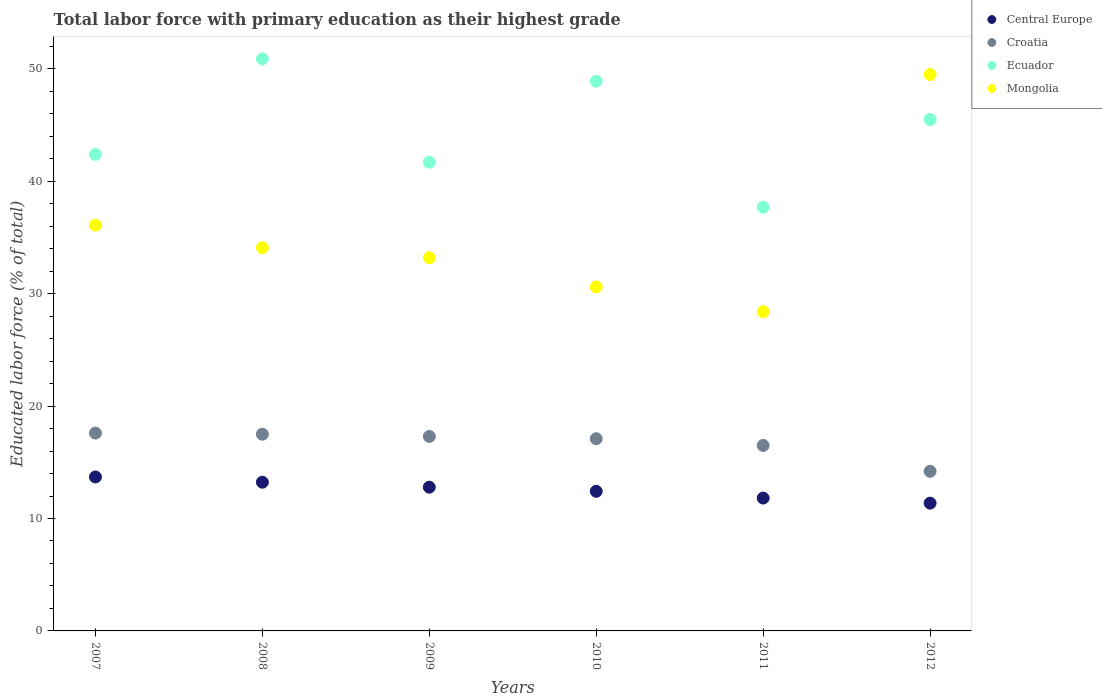What is the percentage of total labor force with primary education in Ecuador in 2009?
Offer a very short reply. 41.7. Across all years, what is the maximum percentage of total labor force with primary education in Ecuador?
Offer a very short reply. 50.9. Across all years, what is the minimum percentage of total labor force with primary education in Central Europe?
Your response must be concise. 11.37. What is the total percentage of total labor force with primary education in Croatia in the graph?
Your response must be concise. 100.2. What is the difference between the percentage of total labor force with primary education in Croatia in 2009 and that in 2010?
Your response must be concise. 0.2. What is the difference between the percentage of total labor force with primary education in Central Europe in 2007 and the percentage of total labor force with primary education in Ecuador in 2010?
Make the answer very short. -35.2. What is the average percentage of total labor force with primary education in Central Europe per year?
Your answer should be very brief. 12.55. In the year 2011, what is the difference between the percentage of total labor force with primary education in Ecuador and percentage of total labor force with primary education in Croatia?
Provide a succinct answer. 21.2. What is the ratio of the percentage of total labor force with primary education in Croatia in 2009 to that in 2010?
Ensure brevity in your answer.  1.01. What is the difference between the highest and the second highest percentage of total labor force with primary education in Mongolia?
Your answer should be very brief. 13.4. What is the difference between the highest and the lowest percentage of total labor force with primary education in Croatia?
Make the answer very short. 3.4. Is it the case that in every year, the sum of the percentage of total labor force with primary education in Ecuador and percentage of total labor force with primary education in Central Europe  is greater than the sum of percentage of total labor force with primary education in Croatia and percentage of total labor force with primary education in Mongolia?
Your answer should be compact. Yes. Does the percentage of total labor force with primary education in Mongolia monotonically increase over the years?
Your answer should be compact. No. How many dotlines are there?
Make the answer very short. 4. What is the difference between two consecutive major ticks on the Y-axis?
Offer a terse response. 10. Does the graph contain grids?
Keep it short and to the point. No. What is the title of the graph?
Your response must be concise. Total labor force with primary education as their highest grade. Does "Slovenia" appear as one of the legend labels in the graph?
Your response must be concise. No. What is the label or title of the Y-axis?
Make the answer very short. Educated labor force (% of total). What is the Educated labor force (% of total) in Central Europe in 2007?
Offer a terse response. 13.7. What is the Educated labor force (% of total) of Croatia in 2007?
Provide a succinct answer. 17.6. What is the Educated labor force (% of total) in Ecuador in 2007?
Your answer should be very brief. 42.4. What is the Educated labor force (% of total) of Mongolia in 2007?
Make the answer very short. 36.1. What is the Educated labor force (% of total) of Central Europe in 2008?
Provide a succinct answer. 13.23. What is the Educated labor force (% of total) of Ecuador in 2008?
Offer a very short reply. 50.9. What is the Educated labor force (% of total) in Mongolia in 2008?
Your answer should be very brief. 34.1. What is the Educated labor force (% of total) of Central Europe in 2009?
Provide a succinct answer. 12.79. What is the Educated labor force (% of total) in Croatia in 2009?
Your answer should be very brief. 17.3. What is the Educated labor force (% of total) in Ecuador in 2009?
Your response must be concise. 41.7. What is the Educated labor force (% of total) in Mongolia in 2009?
Offer a terse response. 33.2. What is the Educated labor force (% of total) of Central Europe in 2010?
Ensure brevity in your answer.  12.42. What is the Educated labor force (% of total) of Croatia in 2010?
Your answer should be very brief. 17.1. What is the Educated labor force (% of total) in Ecuador in 2010?
Provide a short and direct response. 48.9. What is the Educated labor force (% of total) of Mongolia in 2010?
Make the answer very short. 30.6. What is the Educated labor force (% of total) of Central Europe in 2011?
Your answer should be very brief. 11.82. What is the Educated labor force (% of total) of Ecuador in 2011?
Offer a terse response. 37.7. What is the Educated labor force (% of total) in Mongolia in 2011?
Your answer should be compact. 28.4. What is the Educated labor force (% of total) of Central Europe in 2012?
Provide a succinct answer. 11.37. What is the Educated labor force (% of total) in Croatia in 2012?
Make the answer very short. 14.2. What is the Educated labor force (% of total) in Ecuador in 2012?
Provide a succinct answer. 45.5. What is the Educated labor force (% of total) in Mongolia in 2012?
Give a very brief answer. 49.5. Across all years, what is the maximum Educated labor force (% of total) in Central Europe?
Your answer should be compact. 13.7. Across all years, what is the maximum Educated labor force (% of total) of Croatia?
Provide a short and direct response. 17.6. Across all years, what is the maximum Educated labor force (% of total) in Ecuador?
Provide a succinct answer. 50.9. Across all years, what is the maximum Educated labor force (% of total) of Mongolia?
Keep it short and to the point. 49.5. Across all years, what is the minimum Educated labor force (% of total) of Central Europe?
Ensure brevity in your answer.  11.37. Across all years, what is the minimum Educated labor force (% of total) in Croatia?
Offer a terse response. 14.2. Across all years, what is the minimum Educated labor force (% of total) in Ecuador?
Give a very brief answer. 37.7. Across all years, what is the minimum Educated labor force (% of total) in Mongolia?
Ensure brevity in your answer.  28.4. What is the total Educated labor force (% of total) in Central Europe in the graph?
Give a very brief answer. 75.33. What is the total Educated labor force (% of total) of Croatia in the graph?
Your answer should be very brief. 100.2. What is the total Educated labor force (% of total) in Ecuador in the graph?
Give a very brief answer. 267.1. What is the total Educated labor force (% of total) in Mongolia in the graph?
Keep it short and to the point. 211.9. What is the difference between the Educated labor force (% of total) of Central Europe in 2007 and that in 2008?
Your answer should be very brief. 0.47. What is the difference between the Educated labor force (% of total) in Croatia in 2007 and that in 2008?
Ensure brevity in your answer.  0.1. What is the difference between the Educated labor force (% of total) of Mongolia in 2007 and that in 2008?
Give a very brief answer. 2. What is the difference between the Educated labor force (% of total) of Central Europe in 2007 and that in 2009?
Offer a terse response. 0.91. What is the difference between the Educated labor force (% of total) of Croatia in 2007 and that in 2009?
Your response must be concise. 0.3. What is the difference between the Educated labor force (% of total) of Ecuador in 2007 and that in 2009?
Your answer should be very brief. 0.7. What is the difference between the Educated labor force (% of total) of Mongolia in 2007 and that in 2009?
Provide a short and direct response. 2.9. What is the difference between the Educated labor force (% of total) of Central Europe in 2007 and that in 2010?
Offer a terse response. 1.27. What is the difference between the Educated labor force (% of total) of Ecuador in 2007 and that in 2010?
Give a very brief answer. -6.5. What is the difference between the Educated labor force (% of total) in Mongolia in 2007 and that in 2010?
Ensure brevity in your answer.  5.5. What is the difference between the Educated labor force (% of total) of Central Europe in 2007 and that in 2011?
Your response must be concise. 1.88. What is the difference between the Educated labor force (% of total) of Central Europe in 2007 and that in 2012?
Make the answer very short. 2.33. What is the difference between the Educated labor force (% of total) of Mongolia in 2007 and that in 2012?
Ensure brevity in your answer.  -13.4. What is the difference between the Educated labor force (% of total) of Central Europe in 2008 and that in 2009?
Your response must be concise. 0.44. What is the difference between the Educated labor force (% of total) in Ecuador in 2008 and that in 2009?
Offer a very short reply. 9.2. What is the difference between the Educated labor force (% of total) in Mongolia in 2008 and that in 2009?
Keep it short and to the point. 0.9. What is the difference between the Educated labor force (% of total) in Central Europe in 2008 and that in 2010?
Ensure brevity in your answer.  0.81. What is the difference between the Educated labor force (% of total) of Mongolia in 2008 and that in 2010?
Provide a short and direct response. 3.5. What is the difference between the Educated labor force (% of total) of Central Europe in 2008 and that in 2011?
Make the answer very short. 1.41. What is the difference between the Educated labor force (% of total) in Croatia in 2008 and that in 2011?
Your answer should be compact. 1. What is the difference between the Educated labor force (% of total) in Central Europe in 2008 and that in 2012?
Make the answer very short. 1.86. What is the difference between the Educated labor force (% of total) of Croatia in 2008 and that in 2012?
Your answer should be very brief. 3.3. What is the difference between the Educated labor force (% of total) of Mongolia in 2008 and that in 2012?
Provide a succinct answer. -15.4. What is the difference between the Educated labor force (% of total) of Central Europe in 2009 and that in 2010?
Keep it short and to the point. 0.37. What is the difference between the Educated labor force (% of total) in Croatia in 2009 and that in 2010?
Your answer should be very brief. 0.2. What is the difference between the Educated labor force (% of total) in Ecuador in 2009 and that in 2010?
Provide a short and direct response. -7.2. What is the difference between the Educated labor force (% of total) in Central Europe in 2009 and that in 2011?
Offer a very short reply. 0.97. What is the difference between the Educated labor force (% of total) in Ecuador in 2009 and that in 2011?
Keep it short and to the point. 4. What is the difference between the Educated labor force (% of total) in Mongolia in 2009 and that in 2011?
Your response must be concise. 4.8. What is the difference between the Educated labor force (% of total) in Central Europe in 2009 and that in 2012?
Your answer should be compact. 1.42. What is the difference between the Educated labor force (% of total) in Croatia in 2009 and that in 2012?
Offer a terse response. 3.1. What is the difference between the Educated labor force (% of total) of Mongolia in 2009 and that in 2012?
Offer a terse response. -16.3. What is the difference between the Educated labor force (% of total) of Central Europe in 2010 and that in 2011?
Offer a terse response. 0.6. What is the difference between the Educated labor force (% of total) in Central Europe in 2010 and that in 2012?
Keep it short and to the point. 1.05. What is the difference between the Educated labor force (% of total) in Croatia in 2010 and that in 2012?
Keep it short and to the point. 2.9. What is the difference between the Educated labor force (% of total) in Ecuador in 2010 and that in 2012?
Provide a short and direct response. 3.4. What is the difference between the Educated labor force (% of total) in Mongolia in 2010 and that in 2012?
Ensure brevity in your answer.  -18.9. What is the difference between the Educated labor force (% of total) in Central Europe in 2011 and that in 2012?
Provide a short and direct response. 0.45. What is the difference between the Educated labor force (% of total) of Mongolia in 2011 and that in 2012?
Offer a terse response. -21.1. What is the difference between the Educated labor force (% of total) in Central Europe in 2007 and the Educated labor force (% of total) in Croatia in 2008?
Ensure brevity in your answer.  -3.8. What is the difference between the Educated labor force (% of total) of Central Europe in 2007 and the Educated labor force (% of total) of Ecuador in 2008?
Ensure brevity in your answer.  -37.2. What is the difference between the Educated labor force (% of total) of Central Europe in 2007 and the Educated labor force (% of total) of Mongolia in 2008?
Offer a very short reply. -20.4. What is the difference between the Educated labor force (% of total) in Croatia in 2007 and the Educated labor force (% of total) in Ecuador in 2008?
Provide a short and direct response. -33.3. What is the difference between the Educated labor force (% of total) in Croatia in 2007 and the Educated labor force (% of total) in Mongolia in 2008?
Provide a succinct answer. -16.5. What is the difference between the Educated labor force (% of total) in Central Europe in 2007 and the Educated labor force (% of total) in Croatia in 2009?
Keep it short and to the point. -3.6. What is the difference between the Educated labor force (% of total) in Central Europe in 2007 and the Educated labor force (% of total) in Ecuador in 2009?
Offer a terse response. -28. What is the difference between the Educated labor force (% of total) in Central Europe in 2007 and the Educated labor force (% of total) in Mongolia in 2009?
Offer a very short reply. -19.5. What is the difference between the Educated labor force (% of total) in Croatia in 2007 and the Educated labor force (% of total) in Ecuador in 2009?
Provide a succinct answer. -24.1. What is the difference between the Educated labor force (% of total) in Croatia in 2007 and the Educated labor force (% of total) in Mongolia in 2009?
Provide a succinct answer. -15.6. What is the difference between the Educated labor force (% of total) in Ecuador in 2007 and the Educated labor force (% of total) in Mongolia in 2009?
Give a very brief answer. 9.2. What is the difference between the Educated labor force (% of total) of Central Europe in 2007 and the Educated labor force (% of total) of Croatia in 2010?
Your answer should be very brief. -3.4. What is the difference between the Educated labor force (% of total) in Central Europe in 2007 and the Educated labor force (% of total) in Ecuador in 2010?
Provide a succinct answer. -35.2. What is the difference between the Educated labor force (% of total) in Central Europe in 2007 and the Educated labor force (% of total) in Mongolia in 2010?
Ensure brevity in your answer.  -16.9. What is the difference between the Educated labor force (% of total) of Croatia in 2007 and the Educated labor force (% of total) of Ecuador in 2010?
Ensure brevity in your answer.  -31.3. What is the difference between the Educated labor force (% of total) in Central Europe in 2007 and the Educated labor force (% of total) in Croatia in 2011?
Give a very brief answer. -2.8. What is the difference between the Educated labor force (% of total) of Central Europe in 2007 and the Educated labor force (% of total) of Ecuador in 2011?
Keep it short and to the point. -24. What is the difference between the Educated labor force (% of total) of Central Europe in 2007 and the Educated labor force (% of total) of Mongolia in 2011?
Give a very brief answer. -14.7. What is the difference between the Educated labor force (% of total) in Croatia in 2007 and the Educated labor force (% of total) in Ecuador in 2011?
Make the answer very short. -20.1. What is the difference between the Educated labor force (% of total) of Central Europe in 2007 and the Educated labor force (% of total) of Croatia in 2012?
Offer a very short reply. -0.5. What is the difference between the Educated labor force (% of total) in Central Europe in 2007 and the Educated labor force (% of total) in Ecuador in 2012?
Your answer should be compact. -31.8. What is the difference between the Educated labor force (% of total) of Central Europe in 2007 and the Educated labor force (% of total) of Mongolia in 2012?
Keep it short and to the point. -35.8. What is the difference between the Educated labor force (% of total) in Croatia in 2007 and the Educated labor force (% of total) in Ecuador in 2012?
Your answer should be compact. -27.9. What is the difference between the Educated labor force (% of total) of Croatia in 2007 and the Educated labor force (% of total) of Mongolia in 2012?
Your response must be concise. -31.9. What is the difference between the Educated labor force (% of total) in Ecuador in 2007 and the Educated labor force (% of total) in Mongolia in 2012?
Your response must be concise. -7.1. What is the difference between the Educated labor force (% of total) of Central Europe in 2008 and the Educated labor force (% of total) of Croatia in 2009?
Your answer should be compact. -4.07. What is the difference between the Educated labor force (% of total) of Central Europe in 2008 and the Educated labor force (% of total) of Ecuador in 2009?
Provide a succinct answer. -28.47. What is the difference between the Educated labor force (% of total) in Central Europe in 2008 and the Educated labor force (% of total) in Mongolia in 2009?
Provide a short and direct response. -19.97. What is the difference between the Educated labor force (% of total) in Croatia in 2008 and the Educated labor force (% of total) in Ecuador in 2009?
Ensure brevity in your answer.  -24.2. What is the difference between the Educated labor force (% of total) in Croatia in 2008 and the Educated labor force (% of total) in Mongolia in 2009?
Ensure brevity in your answer.  -15.7. What is the difference between the Educated labor force (% of total) of Central Europe in 2008 and the Educated labor force (% of total) of Croatia in 2010?
Offer a terse response. -3.87. What is the difference between the Educated labor force (% of total) of Central Europe in 2008 and the Educated labor force (% of total) of Ecuador in 2010?
Your answer should be very brief. -35.67. What is the difference between the Educated labor force (% of total) in Central Europe in 2008 and the Educated labor force (% of total) in Mongolia in 2010?
Ensure brevity in your answer.  -17.37. What is the difference between the Educated labor force (% of total) of Croatia in 2008 and the Educated labor force (% of total) of Ecuador in 2010?
Keep it short and to the point. -31.4. What is the difference between the Educated labor force (% of total) of Ecuador in 2008 and the Educated labor force (% of total) of Mongolia in 2010?
Give a very brief answer. 20.3. What is the difference between the Educated labor force (% of total) of Central Europe in 2008 and the Educated labor force (% of total) of Croatia in 2011?
Your response must be concise. -3.27. What is the difference between the Educated labor force (% of total) in Central Europe in 2008 and the Educated labor force (% of total) in Ecuador in 2011?
Provide a succinct answer. -24.47. What is the difference between the Educated labor force (% of total) in Central Europe in 2008 and the Educated labor force (% of total) in Mongolia in 2011?
Your answer should be very brief. -15.17. What is the difference between the Educated labor force (% of total) in Croatia in 2008 and the Educated labor force (% of total) in Ecuador in 2011?
Provide a short and direct response. -20.2. What is the difference between the Educated labor force (% of total) in Croatia in 2008 and the Educated labor force (% of total) in Mongolia in 2011?
Give a very brief answer. -10.9. What is the difference between the Educated labor force (% of total) of Central Europe in 2008 and the Educated labor force (% of total) of Croatia in 2012?
Offer a very short reply. -0.97. What is the difference between the Educated labor force (% of total) of Central Europe in 2008 and the Educated labor force (% of total) of Ecuador in 2012?
Make the answer very short. -32.27. What is the difference between the Educated labor force (% of total) in Central Europe in 2008 and the Educated labor force (% of total) in Mongolia in 2012?
Make the answer very short. -36.27. What is the difference between the Educated labor force (% of total) of Croatia in 2008 and the Educated labor force (% of total) of Mongolia in 2012?
Make the answer very short. -32. What is the difference between the Educated labor force (% of total) of Ecuador in 2008 and the Educated labor force (% of total) of Mongolia in 2012?
Make the answer very short. 1.4. What is the difference between the Educated labor force (% of total) of Central Europe in 2009 and the Educated labor force (% of total) of Croatia in 2010?
Provide a short and direct response. -4.31. What is the difference between the Educated labor force (% of total) of Central Europe in 2009 and the Educated labor force (% of total) of Ecuador in 2010?
Your answer should be very brief. -36.11. What is the difference between the Educated labor force (% of total) of Central Europe in 2009 and the Educated labor force (% of total) of Mongolia in 2010?
Offer a very short reply. -17.81. What is the difference between the Educated labor force (% of total) of Croatia in 2009 and the Educated labor force (% of total) of Ecuador in 2010?
Offer a very short reply. -31.6. What is the difference between the Educated labor force (% of total) in Ecuador in 2009 and the Educated labor force (% of total) in Mongolia in 2010?
Ensure brevity in your answer.  11.1. What is the difference between the Educated labor force (% of total) in Central Europe in 2009 and the Educated labor force (% of total) in Croatia in 2011?
Offer a very short reply. -3.71. What is the difference between the Educated labor force (% of total) in Central Europe in 2009 and the Educated labor force (% of total) in Ecuador in 2011?
Provide a short and direct response. -24.91. What is the difference between the Educated labor force (% of total) of Central Europe in 2009 and the Educated labor force (% of total) of Mongolia in 2011?
Your response must be concise. -15.61. What is the difference between the Educated labor force (% of total) in Croatia in 2009 and the Educated labor force (% of total) in Ecuador in 2011?
Provide a succinct answer. -20.4. What is the difference between the Educated labor force (% of total) in Croatia in 2009 and the Educated labor force (% of total) in Mongolia in 2011?
Keep it short and to the point. -11.1. What is the difference between the Educated labor force (% of total) in Ecuador in 2009 and the Educated labor force (% of total) in Mongolia in 2011?
Give a very brief answer. 13.3. What is the difference between the Educated labor force (% of total) in Central Europe in 2009 and the Educated labor force (% of total) in Croatia in 2012?
Your answer should be very brief. -1.41. What is the difference between the Educated labor force (% of total) in Central Europe in 2009 and the Educated labor force (% of total) in Ecuador in 2012?
Provide a succinct answer. -32.71. What is the difference between the Educated labor force (% of total) in Central Europe in 2009 and the Educated labor force (% of total) in Mongolia in 2012?
Make the answer very short. -36.71. What is the difference between the Educated labor force (% of total) of Croatia in 2009 and the Educated labor force (% of total) of Ecuador in 2012?
Your answer should be very brief. -28.2. What is the difference between the Educated labor force (% of total) in Croatia in 2009 and the Educated labor force (% of total) in Mongolia in 2012?
Your answer should be very brief. -32.2. What is the difference between the Educated labor force (% of total) of Central Europe in 2010 and the Educated labor force (% of total) of Croatia in 2011?
Provide a succinct answer. -4.08. What is the difference between the Educated labor force (% of total) of Central Europe in 2010 and the Educated labor force (% of total) of Ecuador in 2011?
Your response must be concise. -25.28. What is the difference between the Educated labor force (% of total) of Central Europe in 2010 and the Educated labor force (% of total) of Mongolia in 2011?
Offer a terse response. -15.98. What is the difference between the Educated labor force (% of total) in Croatia in 2010 and the Educated labor force (% of total) in Ecuador in 2011?
Your answer should be very brief. -20.6. What is the difference between the Educated labor force (% of total) in Ecuador in 2010 and the Educated labor force (% of total) in Mongolia in 2011?
Give a very brief answer. 20.5. What is the difference between the Educated labor force (% of total) in Central Europe in 2010 and the Educated labor force (% of total) in Croatia in 2012?
Make the answer very short. -1.78. What is the difference between the Educated labor force (% of total) of Central Europe in 2010 and the Educated labor force (% of total) of Ecuador in 2012?
Give a very brief answer. -33.08. What is the difference between the Educated labor force (% of total) in Central Europe in 2010 and the Educated labor force (% of total) in Mongolia in 2012?
Keep it short and to the point. -37.08. What is the difference between the Educated labor force (% of total) in Croatia in 2010 and the Educated labor force (% of total) in Ecuador in 2012?
Ensure brevity in your answer.  -28.4. What is the difference between the Educated labor force (% of total) in Croatia in 2010 and the Educated labor force (% of total) in Mongolia in 2012?
Provide a short and direct response. -32.4. What is the difference between the Educated labor force (% of total) of Ecuador in 2010 and the Educated labor force (% of total) of Mongolia in 2012?
Make the answer very short. -0.6. What is the difference between the Educated labor force (% of total) in Central Europe in 2011 and the Educated labor force (% of total) in Croatia in 2012?
Provide a succinct answer. -2.38. What is the difference between the Educated labor force (% of total) in Central Europe in 2011 and the Educated labor force (% of total) in Ecuador in 2012?
Offer a very short reply. -33.68. What is the difference between the Educated labor force (% of total) of Central Europe in 2011 and the Educated labor force (% of total) of Mongolia in 2012?
Ensure brevity in your answer.  -37.68. What is the difference between the Educated labor force (% of total) of Croatia in 2011 and the Educated labor force (% of total) of Mongolia in 2012?
Provide a short and direct response. -33. What is the average Educated labor force (% of total) in Central Europe per year?
Provide a succinct answer. 12.55. What is the average Educated labor force (% of total) in Ecuador per year?
Offer a terse response. 44.52. What is the average Educated labor force (% of total) in Mongolia per year?
Offer a very short reply. 35.32. In the year 2007, what is the difference between the Educated labor force (% of total) in Central Europe and Educated labor force (% of total) in Croatia?
Your answer should be very brief. -3.9. In the year 2007, what is the difference between the Educated labor force (% of total) in Central Europe and Educated labor force (% of total) in Ecuador?
Offer a terse response. -28.7. In the year 2007, what is the difference between the Educated labor force (% of total) of Central Europe and Educated labor force (% of total) of Mongolia?
Give a very brief answer. -22.4. In the year 2007, what is the difference between the Educated labor force (% of total) of Croatia and Educated labor force (% of total) of Ecuador?
Ensure brevity in your answer.  -24.8. In the year 2007, what is the difference between the Educated labor force (% of total) of Croatia and Educated labor force (% of total) of Mongolia?
Keep it short and to the point. -18.5. In the year 2007, what is the difference between the Educated labor force (% of total) of Ecuador and Educated labor force (% of total) of Mongolia?
Your answer should be very brief. 6.3. In the year 2008, what is the difference between the Educated labor force (% of total) of Central Europe and Educated labor force (% of total) of Croatia?
Your answer should be compact. -4.27. In the year 2008, what is the difference between the Educated labor force (% of total) of Central Europe and Educated labor force (% of total) of Ecuador?
Your answer should be compact. -37.67. In the year 2008, what is the difference between the Educated labor force (% of total) in Central Europe and Educated labor force (% of total) in Mongolia?
Your answer should be very brief. -20.87. In the year 2008, what is the difference between the Educated labor force (% of total) of Croatia and Educated labor force (% of total) of Ecuador?
Provide a short and direct response. -33.4. In the year 2008, what is the difference between the Educated labor force (% of total) of Croatia and Educated labor force (% of total) of Mongolia?
Keep it short and to the point. -16.6. In the year 2009, what is the difference between the Educated labor force (% of total) of Central Europe and Educated labor force (% of total) of Croatia?
Your answer should be compact. -4.51. In the year 2009, what is the difference between the Educated labor force (% of total) of Central Europe and Educated labor force (% of total) of Ecuador?
Give a very brief answer. -28.91. In the year 2009, what is the difference between the Educated labor force (% of total) in Central Europe and Educated labor force (% of total) in Mongolia?
Your response must be concise. -20.41. In the year 2009, what is the difference between the Educated labor force (% of total) in Croatia and Educated labor force (% of total) in Ecuador?
Ensure brevity in your answer.  -24.4. In the year 2009, what is the difference between the Educated labor force (% of total) of Croatia and Educated labor force (% of total) of Mongolia?
Make the answer very short. -15.9. In the year 2009, what is the difference between the Educated labor force (% of total) in Ecuador and Educated labor force (% of total) in Mongolia?
Provide a succinct answer. 8.5. In the year 2010, what is the difference between the Educated labor force (% of total) of Central Europe and Educated labor force (% of total) of Croatia?
Ensure brevity in your answer.  -4.68. In the year 2010, what is the difference between the Educated labor force (% of total) of Central Europe and Educated labor force (% of total) of Ecuador?
Offer a terse response. -36.48. In the year 2010, what is the difference between the Educated labor force (% of total) of Central Europe and Educated labor force (% of total) of Mongolia?
Ensure brevity in your answer.  -18.18. In the year 2010, what is the difference between the Educated labor force (% of total) of Croatia and Educated labor force (% of total) of Ecuador?
Give a very brief answer. -31.8. In the year 2010, what is the difference between the Educated labor force (% of total) of Croatia and Educated labor force (% of total) of Mongolia?
Your answer should be very brief. -13.5. In the year 2010, what is the difference between the Educated labor force (% of total) of Ecuador and Educated labor force (% of total) of Mongolia?
Ensure brevity in your answer.  18.3. In the year 2011, what is the difference between the Educated labor force (% of total) of Central Europe and Educated labor force (% of total) of Croatia?
Make the answer very short. -4.68. In the year 2011, what is the difference between the Educated labor force (% of total) of Central Europe and Educated labor force (% of total) of Ecuador?
Your answer should be very brief. -25.88. In the year 2011, what is the difference between the Educated labor force (% of total) of Central Europe and Educated labor force (% of total) of Mongolia?
Your answer should be compact. -16.58. In the year 2011, what is the difference between the Educated labor force (% of total) of Croatia and Educated labor force (% of total) of Ecuador?
Offer a terse response. -21.2. In the year 2011, what is the difference between the Educated labor force (% of total) of Croatia and Educated labor force (% of total) of Mongolia?
Make the answer very short. -11.9. In the year 2012, what is the difference between the Educated labor force (% of total) of Central Europe and Educated labor force (% of total) of Croatia?
Give a very brief answer. -2.83. In the year 2012, what is the difference between the Educated labor force (% of total) of Central Europe and Educated labor force (% of total) of Ecuador?
Provide a short and direct response. -34.13. In the year 2012, what is the difference between the Educated labor force (% of total) of Central Europe and Educated labor force (% of total) of Mongolia?
Keep it short and to the point. -38.13. In the year 2012, what is the difference between the Educated labor force (% of total) in Croatia and Educated labor force (% of total) in Ecuador?
Your response must be concise. -31.3. In the year 2012, what is the difference between the Educated labor force (% of total) of Croatia and Educated labor force (% of total) of Mongolia?
Provide a succinct answer. -35.3. What is the ratio of the Educated labor force (% of total) in Central Europe in 2007 to that in 2008?
Your answer should be compact. 1.04. What is the ratio of the Educated labor force (% of total) in Ecuador in 2007 to that in 2008?
Provide a succinct answer. 0.83. What is the ratio of the Educated labor force (% of total) in Mongolia in 2007 to that in 2008?
Keep it short and to the point. 1.06. What is the ratio of the Educated labor force (% of total) of Central Europe in 2007 to that in 2009?
Provide a short and direct response. 1.07. What is the ratio of the Educated labor force (% of total) of Croatia in 2007 to that in 2009?
Ensure brevity in your answer.  1.02. What is the ratio of the Educated labor force (% of total) of Ecuador in 2007 to that in 2009?
Your answer should be compact. 1.02. What is the ratio of the Educated labor force (% of total) of Mongolia in 2007 to that in 2009?
Your response must be concise. 1.09. What is the ratio of the Educated labor force (% of total) of Central Europe in 2007 to that in 2010?
Offer a very short reply. 1.1. What is the ratio of the Educated labor force (% of total) of Croatia in 2007 to that in 2010?
Offer a very short reply. 1.03. What is the ratio of the Educated labor force (% of total) in Ecuador in 2007 to that in 2010?
Provide a succinct answer. 0.87. What is the ratio of the Educated labor force (% of total) of Mongolia in 2007 to that in 2010?
Your answer should be compact. 1.18. What is the ratio of the Educated labor force (% of total) in Central Europe in 2007 to that in 2011?
Provide a succinct answer. 1.16. What is the ratio of the Educated labor force (% of total) of Croatia in 2007 to that in 2011?
Ensure brevity in your answer.  1.07. What is the ratio of the Educated labor force (% of total) of Ecuador in 2007 to that in 2011?
Provide a short and direct response. 1.12. What is the ratio of the Educated labor force (% of total) in Mongolia in 2007 to that in 2011?
Offer a terse response. 1.27. What is the ratio of the Educated labor force (% of total) of Central Europe in 2007 to that in 2012?
Your answer should be compact. 1.2. What is the ratio of the Educated labor force (% of total) in Croatia in 2007 to that in 2012?
Ensure brevity in your answer.  1.24. What is the ratio of the Educated labor force (% of total) of Ecuador in 2007 to that in 2012?
Give a very brief answer. 0.93. What is the ratio of the Educated labor force (% of total) of Mongolia in 2007 to that in 2012?
Provide a short and direct response. 0.73. What is the ratio of the Educated labor force (% of total) of Central Europe in 2008 to that in 2009?
Offer a terse response. 1.03. What is the ratio of the Educated labor force (% of total) of Croatia in 2008 to that in 2009?
Your answer should be compact. 1.01. What is the ratio of the Educated labor force (% of total) in Ecuador in 2008 to that in 2009?
Offer a terse response. 1.22. What is the ratio of the Educated labor force (% of total) of Mongolia in 2008 to that in 2009?
Offer a terse response. 1.03. What is the ratio of the Educated labor force (% of total) in Central Europe in 2008 to that in 2010?
Offer a very short reply. 1.06. What is the ratio of the Educated labor force (% of total) of Croatia in 2008 to that in 2010?
Ensure brevity in your answer.  1.02. What is the ratio of the Educated labor force (% of total) in Ecuador in 2008 to that in 2010?
Offer a very short reply. 1.04. What is the ratio of the Educated labor force (% of total) in Mongolia in 2008 to that in 2010?
Ensure brevity in your answer.  1.11. What is the ratio of the Educated labor force (% of total) in Central Europe in 2008 to that in 2011?
Provide a short and direct response. 1.12. What is the ratio of the Educated labor force (% of total) of Croatia in 2008 to that in 2011?
Make the answer very short. 1.06. What is the ratio of the Educated labor force (% of total) in Ecuador in 2008 to that in 2011?
Your answer should be compact. 1.35. What is the ratio of the Educated labor force (% of total) in Mongolia in 2008 to that in 2011?
Your answer should be very brief. 1.2. What is the ratio of the Educated labor force (% of total) of Central Europe in 2008 to that in 2012?
Your answer should be very brief. 1.16. What is the ratio of the Educated labor force (% of total) in Croatia in 2008 to that in 2012?
Provide a succinct answer. 1.23. What is the ratio of the Educated labor force (% of total) in Ecuador in 2008 to that in 2012?
Offer a very short reply. 1.12. What is the ratio of the Educated labor force (% of total) of Mongolia in 2008 to that in 2012?
Give a very brief answer. 0.69. What is the ratio of the Educated labor force (% of total) in Central Europe in 2009 to that in 2010?
Provide a short and direct response. 1.03. What is the ratio of the Educated labor force (% of total) of Croatia in 2009 to that in 2010?
Your answer should be very brief. 1.01. What is the ratio of the Educated labor force (% of total) in Ecuador in 2009 to that in 2010?
Offer a very short reply. 0.85. What is the ratio of the Educated labor force (% of total) in Mongolia in 2009 to that in 2010?
Provide a short and direct response. 1.08. What is the ratio of the Educated labor force (% of total) of Central Europe in 2009 to that in 2011?
Give a very brief answer. 1.08. What is the ratio of the Educated labor force (% of total) in Croatia in 2009 to that in 2011?
Give a very brief answer. 1.05. What is the ratio of the Educated labor force (% of total) in Ecuador in 2009 to that in 2011?
Your response must be concise. 1.11. What is the ratio of the Educated labor force (% of total) of Mongolia in 2009 to that in 2011?
Offer a very short reply. 1.17. What is the ratio of the Educated labor force (% of total) of Central Europe in 2009 to that in 2012?
Provide a short and direct response. 1.12. What is the ratio of the Educated labor force (% of total) of Croatia in 2009 to that in 2012?
Your answer should be very brief. 1.22. What is the ratio of the Educated labor force (% of total) in Ecuador in 2009 to that in 2012?
Offer a very short reply. 0.92. What is the ratio of the Educated labor force (% of total) in Mongolia in 2009 to that in 2012?
Give a very brief answer. 0.67. What is the ratio of the Educated labor force (% of total) in Central Europe in 2010 to that in 2011?
Make the answer very short. 1.05. What is the ratio of the Educated labor force (% of total) in Croatia in 2010 to that in 2011?
Your answer should be compact. 1.04. What is the ratio of the Educated labor force (% of total) in Ecuador in 2010 to that in 2011?
Your response must be concise. 1.3. What is the ratio of the Educated labor force (% of total) in Mongolia in 2010 to that in 2011?
Make the answer very short. 1.08. What is the ratio of the Educated labor force (% of total) in Central Europe in 2010 to that in 2012?
Your response must be concise. 1.09. What is the ratio of the Educated labor force (% of total) of Croatia in 2010 to that in 2012?
Your response must be concise. 1.2. What is the ratio of the Educated labor force (% of total) of Ecuador in 2010 to that in 2012?
Provide a short and direct response. 1.07. What is the ratio of the Educated labor force (% of total) of Mongolia in 2010 to that in 2012?
Your answer should be very brief. 0.62. What is the ratio of the Educated labor force (% of total) of Central Europe in 2011 to that in 2012?
Offer a terse response. 1.04. What is the ratio of the Educated labor force (% of total) in Croatia in 2011 to that in 2012?
Give a very brief answer. 1.16. What is the ratio of the Educated labor force (% of total) in Ecuador in 2011 to that in 2012?
Ensure brevity in your answer.  0.83. What is the ratio of the Educated labor force (% of total) in Mongolia in 2011 to that in 2012?
Your response must be concise. 0.57. What is the difference between the highest and the second highest Educated labor force (% of total) of Central Europe?
Your answer should be very brief. 0.47. What is the difference between the highest and the second highest Educated labor force (% of total) in Croatia?
Ensure brevity in your answer.  0.1. What is the difference between the highest and the lowest Educated labor force (% of total) of Central Europe?
Provide a short and direct response. 2.33. What is the difference between the highest and the lowest Educated labor force (% of total) in Croatia?
Your answer should be compact. 3.4. What is the difference between the highest and the lowest Educated labor force (% of total) of Ecuador?
Offer a very short reply. 13.2. What is the difference between the highest and the lowest Educated labor force (% of total) in Mongolia?
Offer a very short reply. 21.1. 